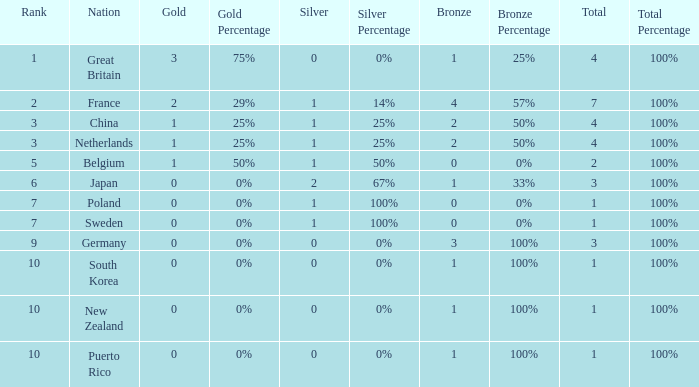What is the rank with 0 bronze? None. 